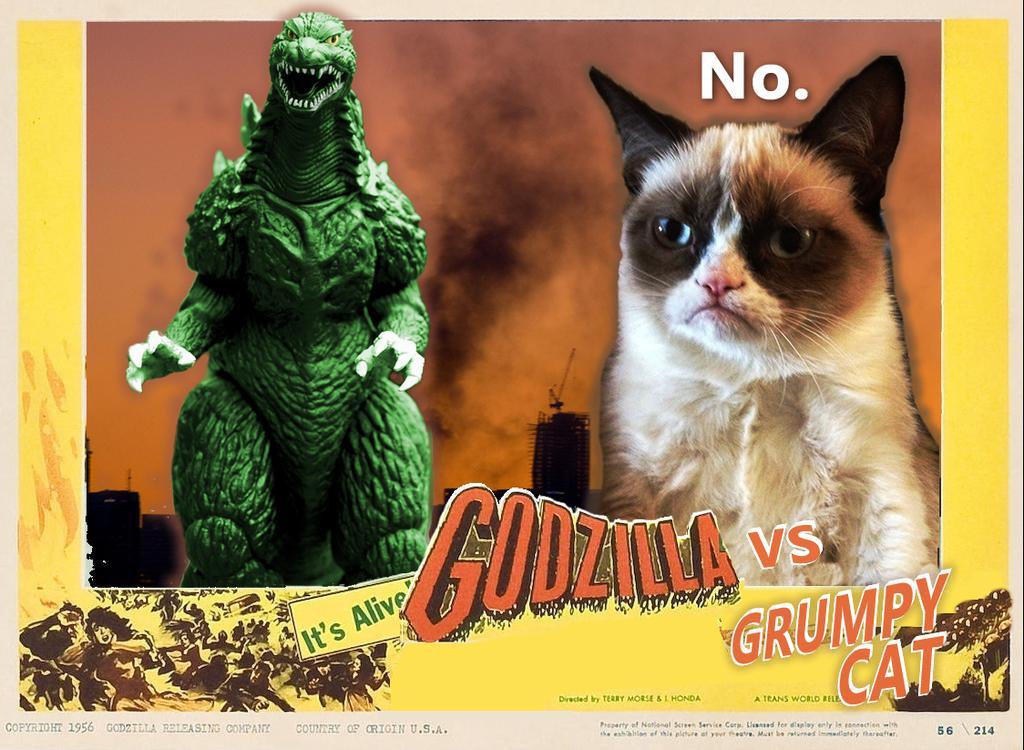In one or two sentences, can you explain what this image depicts? It is a poster. In this image, we can see a cat, Godzilla and text. At the bottom, we can see some figures. 